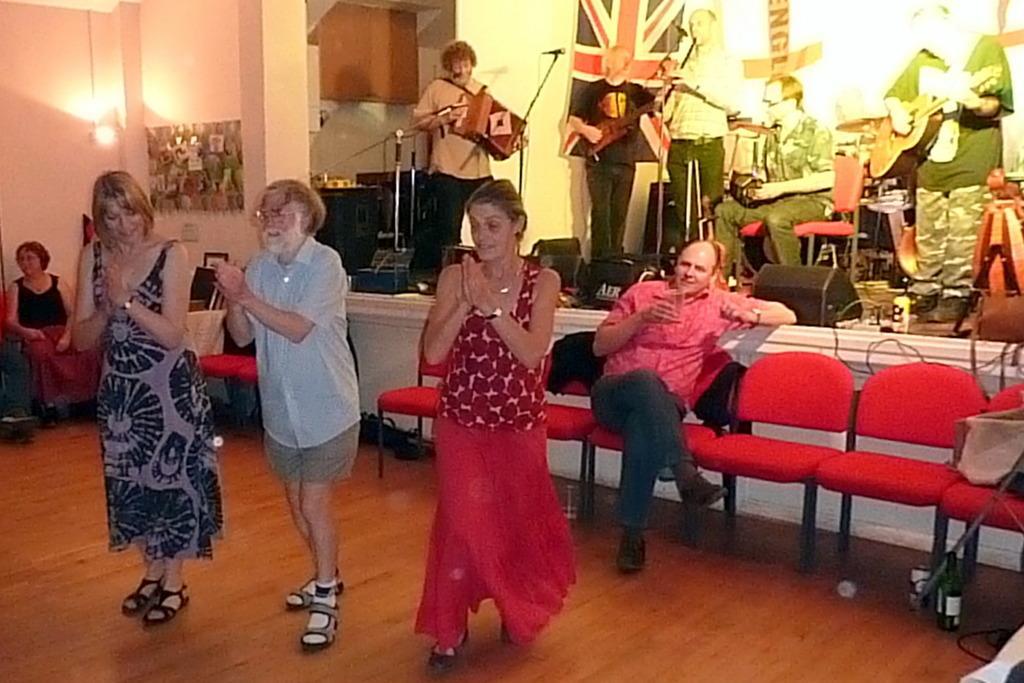How would you summarize this image in a sentence or two? In this image we can see people standing on the floor and some are sitting on the chairs. In the background there are people sitting on the floor and some are standing on the floor by holding musical instruments in their hands. In addition to this we can see pasted on the wall, electric lights, mics attached to the mic stands and cables. 